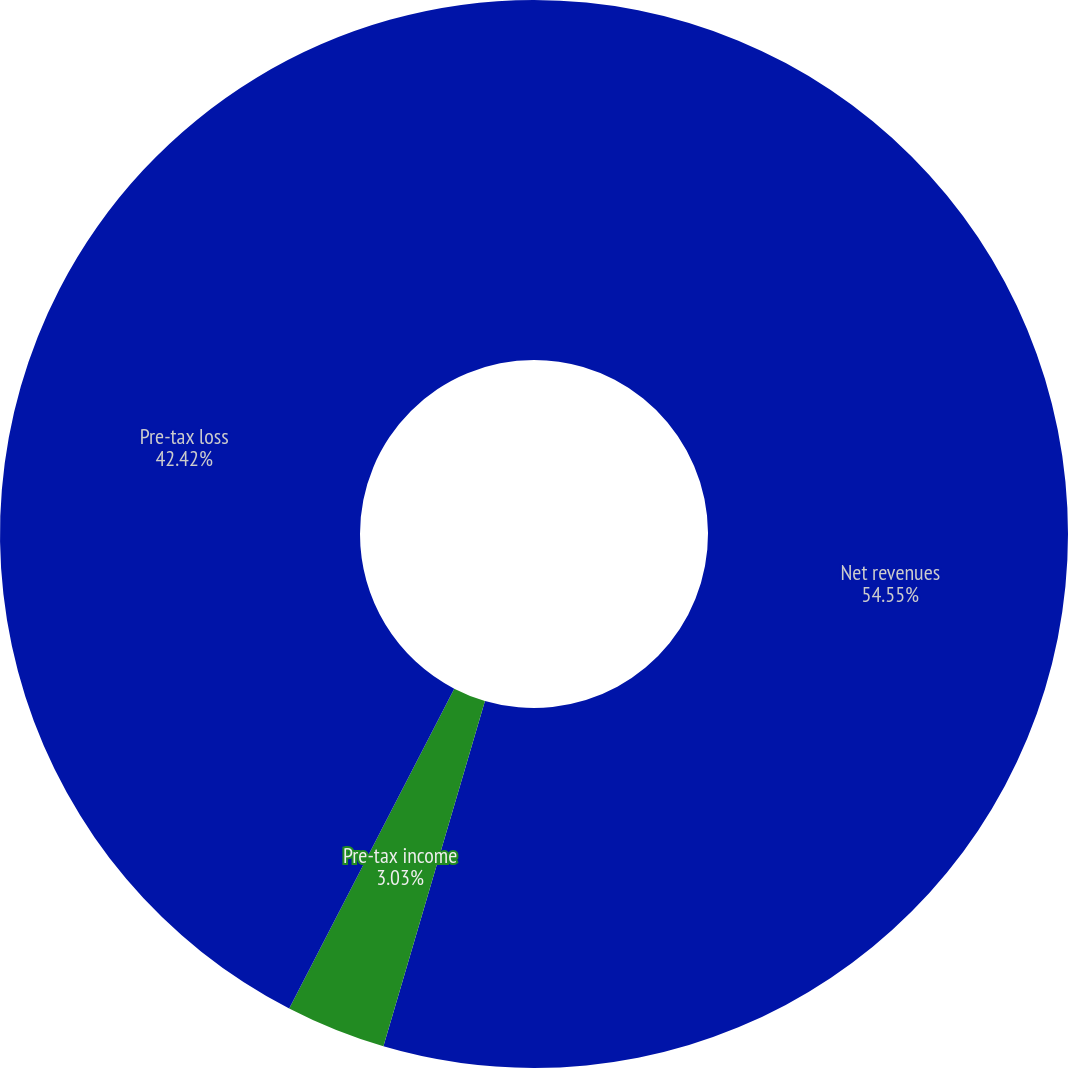Convert chart. <chart><loc_0><loc_0><loc_500><loc_500><pie_chart><fcel>Net revenues<fcel>Pre-tax income<fcel>Pre-tax loss<nl><fcel>54.55%<fcel>3.03%<fcel>42.42%<nl></chart> 